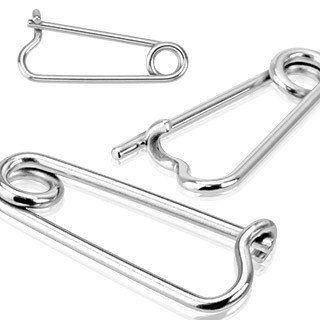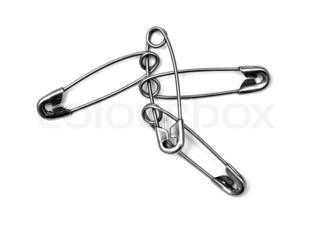The first image is the image on the left, the second image is the image on the right. For the images shown, is this caption "An image shows overlapping safety pins." true? Answer yes or no. Yes. The first image is the image on the left, the second image is the image on the right. For the images displayed, is the sentence "There are more pins in the image on the right." factually correct? Answer yes or no. Yes. 